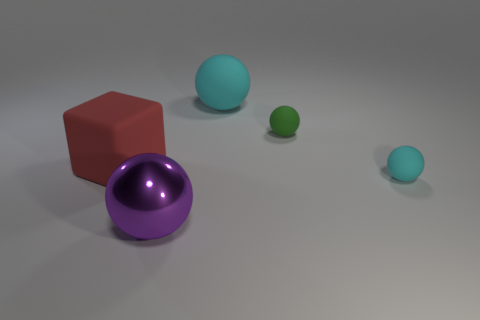Subtract all brown blocks. How many cyan spheres are left? 2 Subtract 2 balls. How many balls are left? 2 Subtract all purple spheres. How many spheres are left? 3 Subtract all big cyan balls. How many balls are left? 3 Add 5 blocks. How many objects exist? 10 Subtract all brown balls. Subtract all gray cylinders. How many balls are left? 4 Subtract 0 brown balls. How many objects are left? 5 Subtract all balls. How many objects are left? 1 Subtract all tiny red metal spheres. Subtract all cyan balls. How many objects are left? 3 Add 2 large cyan spheres. How many large cyan spheres are left? 3 